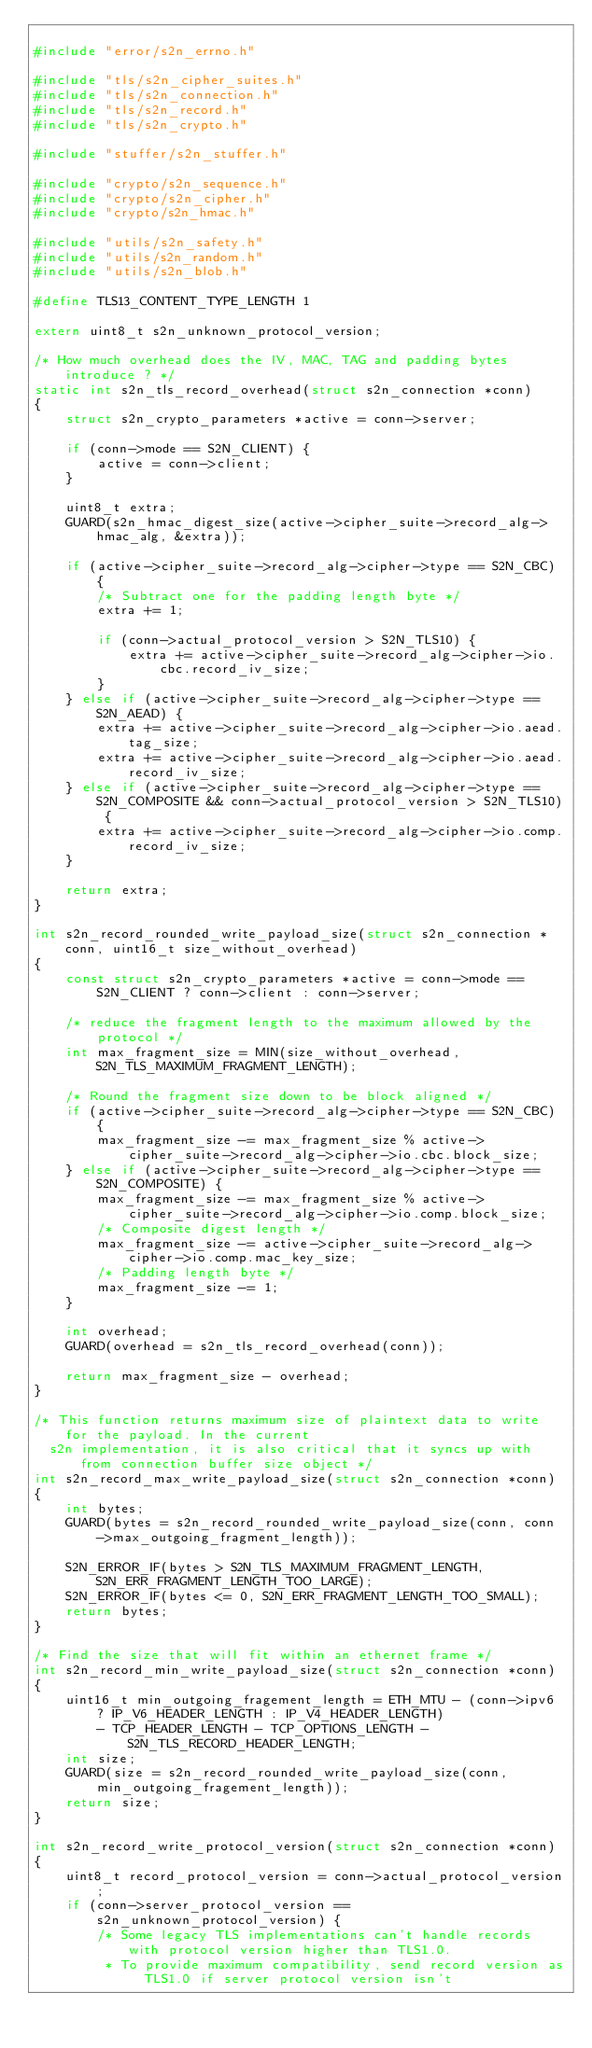<code> <loc_0><loc_0><loc_500><loc_500><_C_>
#include "error/s2n_errno.h"

#include "tls/s2n_cipher_suites.h"
#include "tls/s2n_connection.h"
#include "tls/s2n_record.h"
#include "tls/s2n_crypto.h"

#include "stuffer/s2n_stuffer.h"

#include "crypto/s2n_sequence.h"
#include "crypto/s2n_cipher.h"
#include "crypto/s2n_hmac.h"

#include "utils/s2n_safety.h"
#include "utils/s2n_random.h"
#include "utils/s2n_blob.h"

#define TLS13_CONTENT_TYPE_LENGTH 1

extern uint8_t s2n_unknown_protocol_version;

/* How much overhead does the IV, MAC, TAG and padding bytes introduce ? */
static int s2n_tls_record_overhead(struct s2n_connection *conn)
{
    struct s2n_crypto_parameters *active = conn->server;

    if (conn->mode == S2N_CLIENT) {
        active = conn->client;
    }

    uint8_t extra;
    GUARD(s2n_hmac_digest_size(active->cipher_suite->record_alg->hmac_alg, &extra));

    if (active->cipher_suite->record_alg->cipher->type == S2N_CBC) {
        /* Subtract one for the padding length byte */
        extra += 1;

        if (conn->actual_protocol_version > S2N_TLS10) {
            extra += active->cipher_suite->record_alg->cipher->io.cbc.record_iv_size;
        }
    } else if (active->cipher_suite->record_alg->cipher->type == S2N_AEAD) {
        extra += active->cipher_suite->record_alg->cipher->io.aead.tag_size;
        extra += active->cipher_suite->record_alg->cipher->io.aead.record_iv_size;
    } else if (active->cipher_suite->record_alg->cipher->type == S2N_COMPOSITE && conn->actual_protocol_version > S2N_TLS10) {
        extra += active->cipher_suite->record_alg->cipher->io.comp.record_iv_size;
    }

    return extra;
}

int s2n_record_rounded_write_payload_size(struct s2n_connection *conn, uint16_t size_without_overhead)
{
    const struct s2n_crypto_parameters *active = conn->mode == S2N_CLIENT ? conn->client : conn->server;

    /* reduce the fragment length to the maximum allowed by the protocol */
    int max_fragment_size = MIN(size_without_overhead, S2N_TLS_MAXIMUM_FRAGMENT_LENGTH);

    /* Round the fragment size down to be block aligned */
    if (active->cipher_suite->record_alg->cipher->type == S2N_CBC) {
        max_fragment_size -= max_fragment_size % active->cipher_suite->record_alg->cipher->io.cbc.block_size;
    } else if (active->cipher_suite->record_alg->cipher->type == S2N_COMPOSITE) {
        max_fragment_size -= max_fragment_size % active->cipher_suite->record_alg->cipher->io.comp.block_size;
        /* Composite digest length */
        max_fragment_size -= active->cipher_suite->record_alg->cipher->io.comp.mac_key_size;
        /* Padding length byte */
        max_fragment_size -= 1;
    }

    int overhead;
    GUARD(overhead = s2n_tls_record_overhead(conn));

    return max_fragment_size - overhead;
}

/* This function returns maximum size of plaintext data to write for the payload. In the current
  s2n implementation, it is also critical that it syncs up with from connection buffer size object */
int s2n_record_max_write_payload_size(struct s2n_connection *conn)
{
    int bytes;
    GUARD(bytes = s2n_record_rounded_write_payload_size(conn, conn->max_outgoing_fragment_length));

    S2N_ERROR_IF(bytes > S2N_TLS_MAXIMUM_FRAGMENT_LENGTH, S2N_ERR_FRAGMENT_LENGTH_TOO_LARGE);
    S2N_ERROR_IF(bytes <= 0, S2N_ERR_FRAGMENT_LENGTH_TOO_SMALL);
    return bytes;
}

/* Find the size that will fit within an ethernet frame */
int s2n_record_min_write_payload_size(struct s2n_connection *conn)
{
    uint16_t min_outgoing_fragement_length = ETH_MTU - (conn->ipv6 ? IP_V6_HEADER_LENGTH : IP_V4_HEADER_LENGTH)
        - TCP_HEADER_LENGTH - TCP_OPTIONS_LENGTH - S2N_TLS_RECORD_HEADER_LENGTH;
    int size;
    GUARD(size = s2n_record_rounded_write_payload_size(conn, min_outgoing_fragement_length));
    return size;
}

int s2n_record_write_protocol_version(struct s2n_connection *conn)
{
    uint8_t record_protocol_version = conn->actual_protocol_version;
    if (conn->server_protocol_version == s2n_unknown_protocol_version) {
        /* Some legacy TLS implementations can't handle records with protocol version higher than TLS1.0.
         * To provide maximum compatibility, send record version as TLS1.0 if server protocol version isn't</code> 